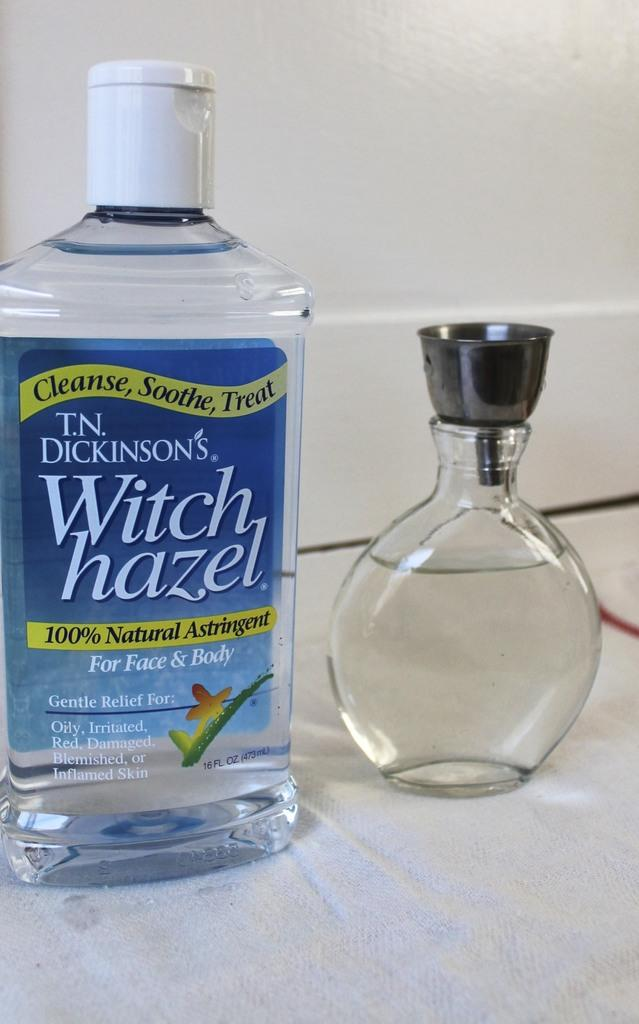What is on the bottle that is visible in the image? There is a label on the bottle. Where is the bottle located in the image? The bottle is on a table. Can you describe the bottle in more detail? The bottle is a glass bottle with a steel cap. Where is the glass bottle located in the image? The glass bottle is also on a table. Are there any fangs visible on the bottle in the image? No, there are no fangs present on the bottle in the image. 